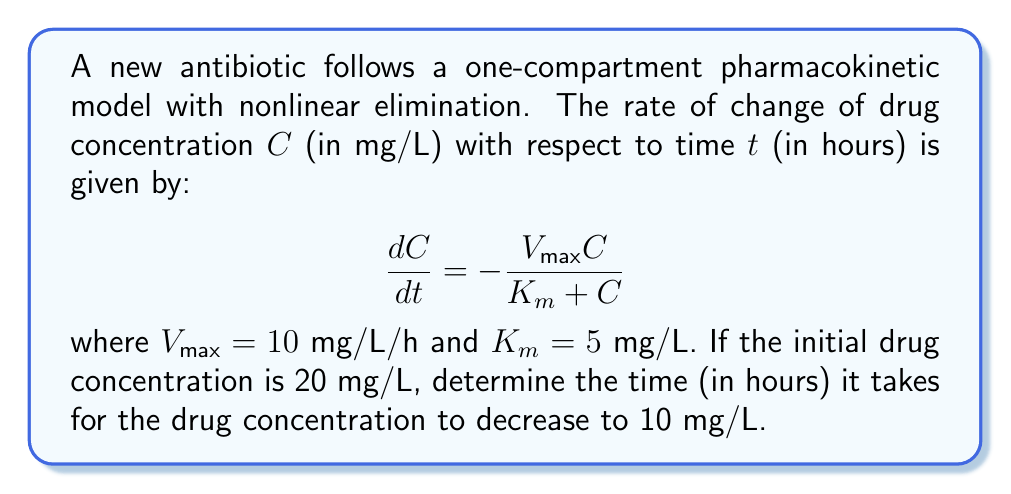Teach me how to tackle this problem. To solve this problem, we need to use the given nonlinear differential equation and integrate it. Let's approach this step-by-step:

1) The differential equation is:

   $$\frac{dC}{dt} = -\frac{V_{\text{max}}C}{K_m + C}$$

2) Rearranging the equation:

   $$dt = -\frac{K_m + C}{V_{\text{max}}C}dC$$

3) Integrating both sides from $t=0$ to $t$ and $C=20$ to $C=10$:

   $$\int_0^t dt = -\int_{20}^{10} \frac{K_m + C}{V_{\text{max}}C}dC$$

4) Solving the right-hand side:

   $$t = -\frac{1}{V_{\text{max}}} \int_{20}^{10} (\frac{K_m}{C} + 1)dC$$
   
   $$t = -\frac{1}{V_{\text{max}}} [K_m \ln(C) + C]_{20}^{10}$$

5) Substituting the values:

   $$t = -\frac{1}{10} [(5 \ln(10) + 10) - (5 \ln(20) + 20)]$$

6) Simplifying:

   $$t = -\frac{1}{10} [5 \ln(10) + 10 - 5 \ln(20) - 20]$$
   $$t = -\frac{1}{10} [5 (\ln(10) - \ln(20)) - 10]$$
   $$t = -\frac{1}{10} [5 \ln(\frac{1}{2}) - 10]$$
   $$t = -\frac{1}{10} [-5 \ln(2) - 10]$$
   $$t = \frac{5 \ln(2) + 10}{10}$$
   $$t = 0.5 \ln(2) + 1$$

7) Calculating the final result:

   $$t \approx 1.3466$$ hours
Answer: $1.3466$ hours 